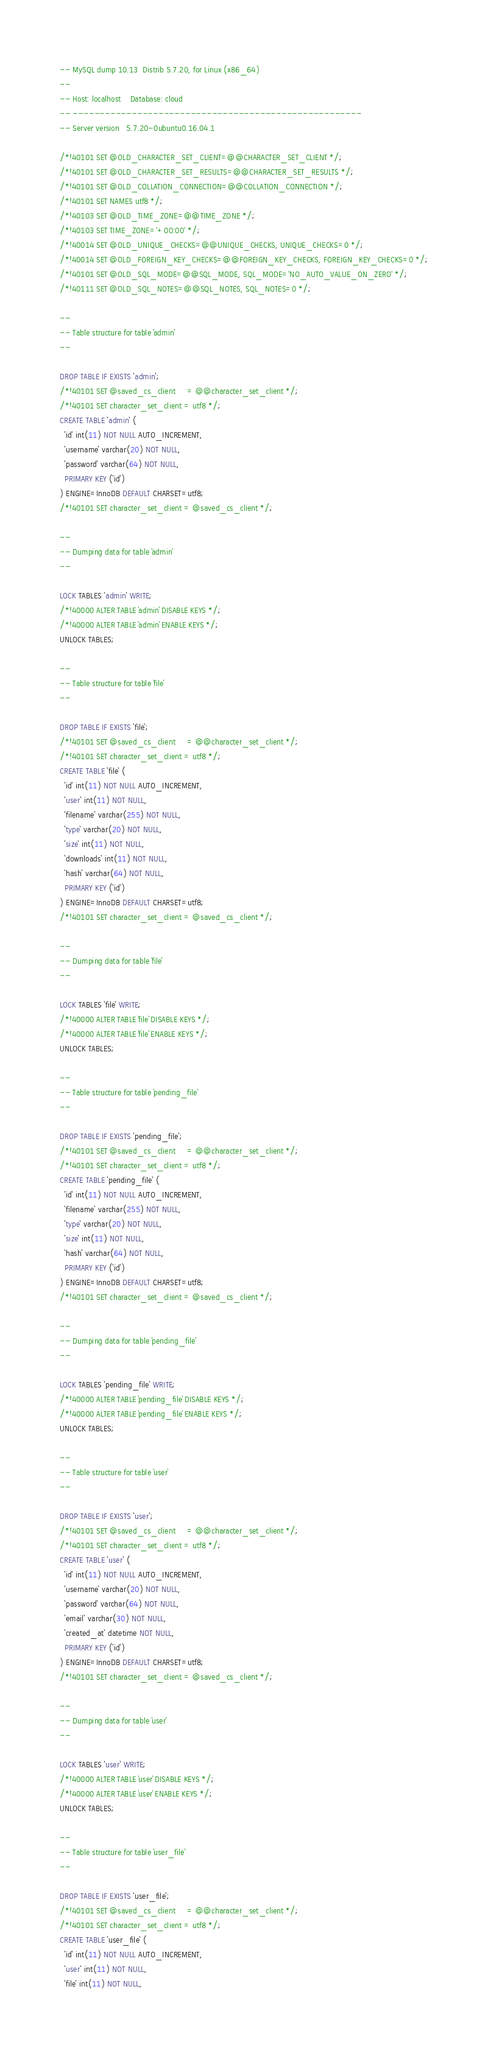Convert code to text. <code><loc_0><loc_0><loc_500><loc_500><_SQL_>-- MySQL dump 10.13  Distrib 5.7.20, for Linux (x86_64)
--
-- Host: localhost    Database: cloud
-- ------------------------------------------------------
-- Server version	5.7.20-0ubuntu0.16.04.1

/*!40101 SET @OLD_CHARACTER_SET_CLIENT=@@CHARACTER_SET_CLIENT */;
/*!40101 SET @OLD_CHARACTER_SET_RESULTS=@@CHARACTER_SET_RESULTS */;
/*!40101 SET @OLD_COLLATION_CONNECTION=@@COLLATION_CONNECTION */;
/*!40101 SET NAMES utf8 */;
/*!40103 SET @OLD_TIME_ZONE=@@TIME_ZONE */;
/*!40103 SET TIME_ZONE='+00:00' */;
/*!40014 SET @OLD_UNIQUE_CHECKS=@@UNIQUE_CHECKS, UNIQUE_CHECKS=0 */;
/*!40014 SET @OLD_FOREIGN_KEY_CHECKS=@@FOREIGN_KEY_CHECKS, FOREIGN_KEY_CHECKS=0 */;
/*!40101 SET @OLD_SQL_MODE=@@SQL_MODE, SQL_MODE='NO_AUTO_VALUE_ON_ZERO' */;
/*!40111 SET @OLD_SQL_NOTES=@@SQL_NOTES, SQL_NOTES=0 */;

--
-- Table structure for table `admin`
--

DROP TABLE IF EXISTS `admin`;
/*!40101 SET @saved_cs_client     = @@character_set_client */;
/*!40101 SET character_set_client = utf8 */;
CREATE TABLE `admin` (
  `id` int(11) NOT NULL AUTO_INCREMENT,
  `username` varchar(20) NOT NULL,
  `password` varchar(64) NOT NULL,
  PRIMARY KEY (`id`)
) ENGINE=InnoDB DEFAULT CHARSET=utf8;
/*!40101 SET character_set_client = @saved_cs_client */;

--
-- Dumping data for table `admin`
--

LOCK TABLES `admin` WRITE;
/*!40000 ALTER TABLE `admin` DISABLE KEYS */;
/*!40000 ALTER TABLE `admin` ENABLE KEYS */;
UNLOCK TABLES;

--
-- Table structure for table `file`
--

DROP TABLE IF EXISTS `file`;
/*!40101 SET @saved_cs_client     = @@character_set_client */;
/*!40101 SET character_set_client = utf8 */;
CREATE TABLE `file` (
  `id` int(11) NOT NULL AUTO_INCREMENT,
  `user` int(11) NOT NULL,
  `filename` varchar(255) NOT NULL,
  `type` varchar(20) NOT NULL,
  `size` int(11) NOT NULL,
  `downloads` int(11) NOT NULL,
  `hash` varchar(64) NOT NULL,
  PRIMARY KEY (`id`)
) ENGINE=InnoDB DEFAULT CHARSET=utf8;
/*!40101 SET character_set_client = @saved_cs_client */;

--
-- Dumping data for table `file`
--

LOCK TABLES `file` WRITE;
/*!40000 ALTER TABLE `file` DISABLE KEYS */;
/*!40000 ALTER TABLE `file` ENABLE KEYS */;
UNLOCK TABLES;

--
-- Table structure for table `pending_file`
--

DROP TABLE IF EXISTS `pending_file`;
/*!40101 SET @saved_cs_client     = @@character_set_client */;
/*!40101 SET character_set_client = utf8 */;
CREATE TABLE `pending_file` (
  `id` int(11) NOT NULL AUTO_INCREMENT,
  `filename` varchar(255) NOT NULL,
  `type` varchar(20) NOT NULL,
  `size` int(11) NOT NULL,
  `hash` varchar(64) NOT NULL,
  PRIMARY KEY (`id`)
) ENGINE=InnoDB DEFAULT CHARSET=utf8;
/*!40101 SET character_set_client = @saved_cs_client */;

--
-- Dumping data for table `pending_file`
--

LOCK TABLES `pending_file` WRITE;
/*!40000 ALTER TABLE `pending_file` DISABLE KEYS */;
/*!40000 ALTER TABLE `pending_file` ENABLE KEYS */;
UNLOCK TABLES;

--
-- Table structure for table `user`
--

DROP TABLE IF EXISTS `user`;
/*!40101 SET @saved_cs_client     = @@character_set_client */;
/*!40101 SET character_set_client = utf8 */;
CREATE TABLE `user` (
  `id` int(11) NOT NULL AUTO_INCREMENT,
  `username` varchar(20) NOT NULL,
  `password` varchar(64) NOT NULL,
  `email` varchar(30) NOT NULL,
  `created_at` datetime NOT NULL,
  PRIMARY KEY (`id`)
) ENGINE=InnoDB DEFAULT CHARSET=utf8;
/*!40101 SET character_set_client = @saved_cs_client */;

--
-- Dumping data for table `user`
--

LOCK TABLES `user` WRITE;
/*!40000 ALTER TABLE `user` DISABLE KEYS */;
/*!40000 ALTER TABLE `user` ENABLE KEYS */;
UNLOCK TABLES;

--
-- Table structure for table `user_file`
--

DROP TABLE IF EXISTS `user_file`;
/*!40101 SET @saved_cs_client     = @@character_set_client */;
/*!40101 SET character_set_client = utf8 */;
CREATE TABLE `user_file` (
  `id` int(11) NOT NULL AUTO_INCREMENT,
  `user` int(11) NOT NULL,
  `file` int(11) NOT NULL,</code> 